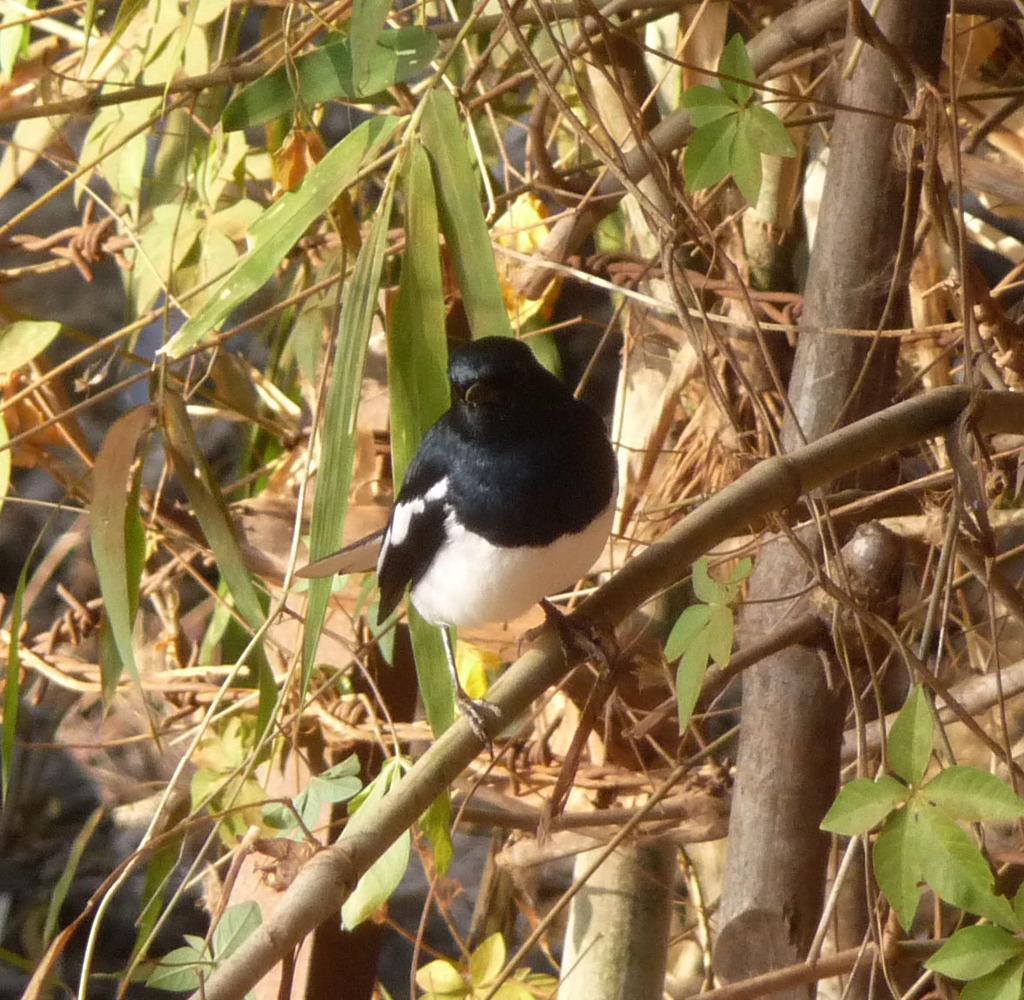Could you give a brief overview of what you see in this image? Here I can see a bird on a plant. This is in black and white colors. Here I can see the green color leaves and stems. 